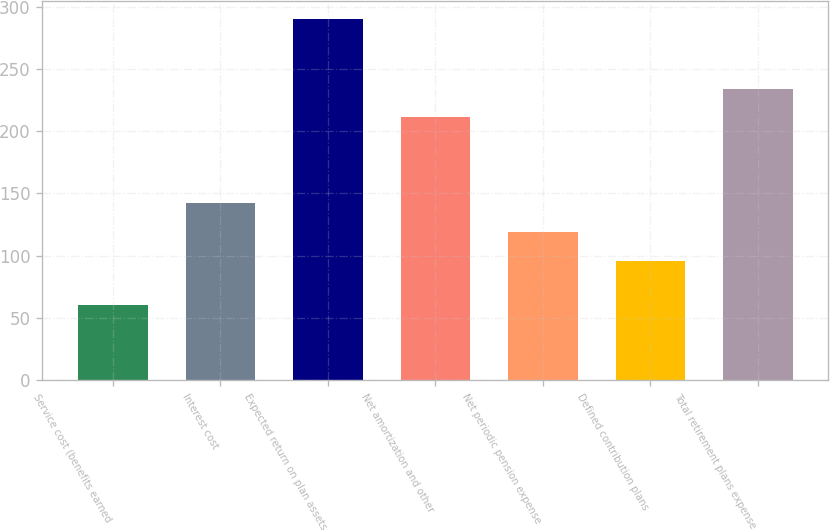Convert chart to OTSL. <chart><loc_0><loc_0><loc_500><loc_500><bar_chart><fcel>Service cost (benefits earned<fcel>Interest cost<fcel>Expected return on plan assets<fcel>Net amortization and other<fcel>Net periodic pension expense<fcel>Defined contribution plans<fcel>Total retirement plans expense<nl><fcel>60<fcel>142<fcel>290<fcel>211<fcel>119<fcel>96<fcel>234<nl></chart> 